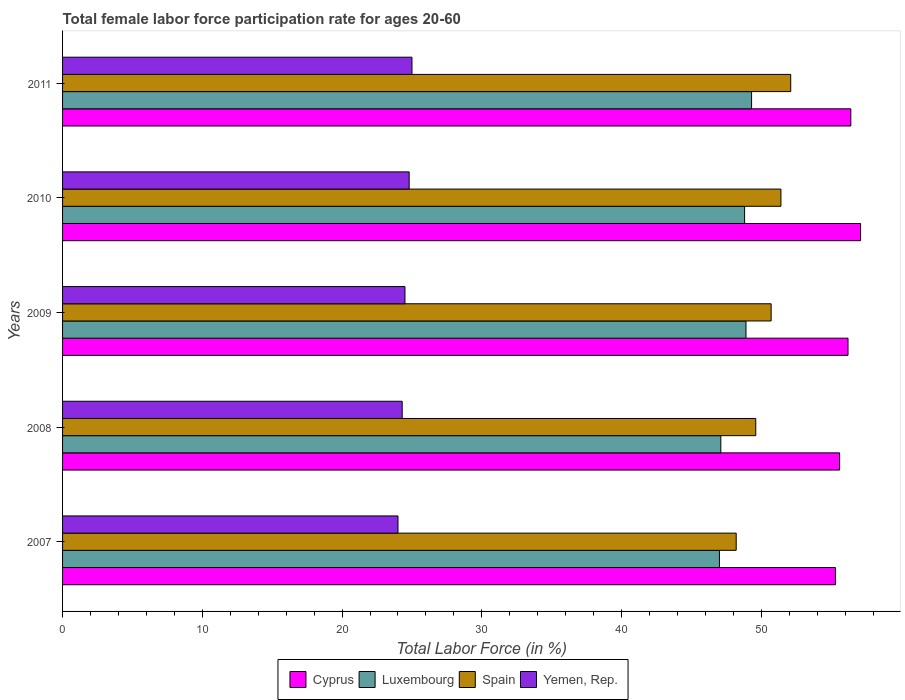How many different coloured bars are there?
Offer a terse response. 4. How many groups of bars are there?
Your answer should be compact. 5. Are the number of bars per tick equal to the number of legend labels?
Keep it short and to the point. Yes. Are the number of bars on each tick of the Y-axis equal?
Ensure brevity in your answer.  Yes. How many bars are there on the 1st tick from the top?
Ensure brevity in your answer.  4. What is the label of the 1st group of bars from the top?
Your answer should be very brief. 2011. In how many cases, is the number of bars for a given year not equal to the number of legend labels?
Your answer should be compact. 0. What is the female labor force participation rate in Spain in 2009?
Provide a short and direct response. 50.7. Across all years, what is the maximum female labor force participation rate in Luxembourg?
Your answer should be compact. 49.3. Across all years, what is the minimum female labor force participation rate in Spain?
Offer a very short reply. 48.2. In which year was the female labor force participation rate in Spain maximum?
Offer a terse response. 2011. What is the total female labor force participation rate in Spain in the graph?
Keep it short and to the point. 252. What is the difference between the female labor force participation rate in Luxembourg in 2009 and that in 2010?
Your response must be concise. 0.1. What is the difference between the female labor force participation rate in Yemen, Rep. in 2009 and the female labor force participation rate in Spain in 2011?
Provide a succinct answer. -27.6. What is the average female labor force participation rate in Spain per year?
Offer a very short reply. 50.4. In the year 2011, what is the difference between the female labor force participation rate in Spain and female labor force participation rate in Yemen, Rep.?
Offer a very short reply. 27.1. What is the ratio of the female labor force participation rate in Luxembourg in 2008 to that in 2010?
Keep it short and to the point. 0.97. Is the female labor force participation rate in Luxembourg in 2009 less than that in 2011?
Your answer should be compact. Yes. Is the difference between the female labor force participation rate in Spain in 2009 and 2010 greater than the difference between the female labor force participation rate in Yemen, Rep. in 2009 and 2010?
Keep it short and to the point. No. What is the difference between the highest and the second highest female labor force participation rate in Luxembourg?
Your answer should be compact. 0.4. What is the difference between the highest and the lowest female labor force participation rate in Spain?
Your answer should be very brief. 3.9. Is it the case that in every year, the sum of the female labor force participation rate in Luxembourg and female labor force participation rate in Yemen, Rep. is greater than the sum of female labor force participation rate in Spain and female labor force participation rate in Cyprus?
Your answer should be compact. Yes. What does the 4th bar from the top in 2008 represents?
Keep it short and to the point. Cyprus. What does the 2nd bar from the bottom in 2007 represents?
Give a very brief answer. Luxembourg. Is it the case that in every year, the sum of the female labor force participation rate in Cyprus and female labor force participation rate in Luxembourg is greater than the female labor force participation rate in Yemen, Rep.?
Keep it short and to the point. Yes. How many bars are there?
Make the answer very short. 20. Are all the bars in the graph horizontal?
Your answer should be very brief. Yes. How many years are there in the graph?
Provide a short and direct response. 5. What is the difference between two consecutive major ticks on the X-axis?
Your response must be concise. 10. Does the graph contain any zero values?
Your response must be concise. No. Does the graph contain grids?
Give a very brief answer. No. How many legend labels are there?
Your response must be concise. 4. How are the legend labels stacked?
Make the answer very short. Horizontal. What is the title of the graph?
Keep it short and to the point. Total female labor force participation rate for ages 20-60. What is the label or title of the X-axis?
Offer a terse response. Total Labor Force (in %). What is the Total Labor Force (in %) of Cyprus in 2007?
Ensure brevity in your answer.  55.3. What is the Total Labor Force (in %) of Luxembourg in 2007?
Keep it short and to the point. 47. What is the Total Labor Force (in %) of Spain in 2007?
Your response must be concise. 48.2. What is the Total Labor Force (in %) in Yemen, Rep. in 2007?
Your answer should be very brief. 24. What is the Total Labor Force (in %) of Cyprus in 2008?
Ensure brevity in your answer.  55.6. What is the Total Labor Force (in %) of Luxembourg in 2008?
Your answer should be very brief. 47.1. What is the Total Labor Force (in %) of Spain in 2008?
Provide a short and direct response. 49.6. What is the Total Labor Force (in %) of Yemen, Rep. in 2008?
Provide a succinct answer. 24.3. What is the Total Labor Force (in %) in Cyprus in 2009?
Your answer should be compact. 56.2. What is the Total Labor Force (in %) of Luxembourg in 2009?
Ensure brevity in your answer.  48.9. What is the Total Labor Force (in %) in Spain in 2009?
Give a very brief answer. 50.7. What is the Total Labor Force (in %) of Yemen, Rep. in 2009?
Your answer should be compact. 24.5. What is the Total Labor Force (in %) in Cyprus in 2010?
Your answer should be compact. 57.1. What is the Total Labor Force (in %) of Luxembourg in 2010?
Your answer should be compact. 48.8. What is the Total Labor Force (in %) of Spain in 2010?
Keep it short and to the point. 51.4. What is the Total Labor Force (in %) of Yemen, Rep. in 2010?
Keep it short and to the point. 24.8. What is the Total Labor Force (in %) of Cyprus in 2011?
Your answer should be very brief. 56.4. What is the Total Labor Force (in %) of Luxembourg in 2011?
Provide a succinct answer. 49.3. What is the Total Labor Force (in %) of Spain in 2011?
Offer a very short reply. 52.1. What is the Total Labor Force (in %) of Yemen, Rep. in 2011?
Your response must be concise. 25. Across all years, what is the maximum Total Labor Force (in %) in Cyprus?
Your answer should be very brief. 57.1. Across all years, what is the maximum Total Labor Force (in %) of Luxembourg?
Your answer should be very brief. 49.3. Across all years, what is the maximum Total Labor Force (in %) of Spain?
Your answer should be very brief. 52.1. Across all years, what is the maximum Total Labor Force (in %) in Yemen, Rep.?
Keep it short and to the point. 25. Across all years, what is the minimum Total Labor Force (in %) in Cyprus?
Your answer should be compact. 55.3. Across all years, what is the minimum Total Labor Force (in %) of Spain?
Your answer should be very brief. 48.2. Across all years, what is the minimum Total Labor Force (in %) of Yemen, Rep.?
Ensure brevity in your answer.  24. What is the total Total Labor Force (in %) of Cyprus in the graph?
Your response must be concise. 280.6. What is the total Total Labor Force (in %) of Luxembourg in the graph?
Offer a very short reply. 241.1. What is the total Total Labor Force (in %) of Spain in the graph?
Offer a very short reply. 252. What is the total Total Labor Force (in %) of Yemen, Rep. in the graph?
Give a very brief answer. 122.6. What is the difference between the Total Labor Force (in %) in Cyprus in 2007 and that in 2008?
Give a very brief answer. -0.3. What is the difference between the Total Labor Force (in %) in Spain in 2007 and that in 2008?
Your answer should be compact. -1.4. What is the difference between the Total Labor Force (in %) of Yemen, Rep. in 2007 and that in 2008?
Make the answer very short. -0.3. What is the difference between the Total Labor Force (in %) in Cyprus in 2007 and that in 2009?
Give a very brief answer. -0.9. What is the difference between the Total Labor Force (in %) in Luxembourg in 2007 and that in 2009?
Your answer should be very brief. -1.9. What is the difference between the Total Labor Force (in %) of Cyprus in 2007 and that in 2010?
Provide a short and direct response. -1.8. What is the difference between the Total Labor Force (in %) in Luxembourg in 2007 and that in 2010?
Your answer should be compact. -1.8. What is the difference between the Total Labor Force (in %) of Cyprus in 2007 and that in 2011?
Offer a terse response. -1.1. What is the difference between the Total Labor Force (in %) of Spain in 2007 and that in 2011?
Provide a short and direct response. -3.9. What is the difference between the Total Labor Force (in %) of Yemen, Rep. in 2007 and that in 2011?
Make the answer very short. -1. What is the difference between the Total Labor Force (in %) in Luxembourg in 2008 and that in 2009?
Provide a short and direct response. -1.8. What is the difference between the Total Labor Force (in %) in Spain in 2008 and that in 2009?
Your answer should be compact. -1.1. What is the difference between the Total Labor Force (in %) in Cyprus in 2008 and that in 2010?
Your answer should be very brief. -1.5. What is the difference between the Total Labor Force (in %) in Luxembourg in 2008 and that in 2010?
Offer a terse response. -1.7. What is the difference between the Total Labor Force (in %) of Yemen, Rep. in 2008 and that in 2010?
Keep it short and to the point. -0.5. What is the difference between the Total Labor Force (in %) in Cyprus in 2008 and that in 2011?
Provide a short and direct response. -0.8. What is the difference between the Total Labor Force (in %) in Luxembourg in 2008 and that in 2011?
Offer a very short reply. -2.2. What is the difference between the Total Labor Force (in %) of Luxembourg in 2009 and that in 2010?
Your answer should be very brief. 0.1. What is the difference between the Total Labor Force (in %) of Yemen, Rep. in 2009 and that in 2010?
Ensure brevity in your answer.  -0.3. What is the difference between the Total Labor Force (in %) in Cyprus in 2009 and that in 2011?
Your response must be concise. -0.2. What is the difference between the Total Labor Force (in %) of Spain in 2009 and that in 2011?
Offer a terse response. -1.4. What is the difference between the Total Labor Force (in %) of Yemen, Rep. in 2009 and that in 2011?
Provide a succinct answer. -0.5. What is the difference between the Total Labor Force (in %) of Cyprus in 2010 and that in 2011?
Your answer should be compact. 0.7. What is the difference between the Total Labor Force (in %) in Cyprus in 2007 and the Total Labor Force (in %) in Spain in 2008?
Provide a succinct answer. 5.7. What is the difference between the Total Labor Force (in %) in Luxembourg in 2007 and the Total Labor Force (in %) in Spain in 2008?
Ensure brevity in your answer.  -2.6. What is the difference between the Total Labor Force (in %) in Luxembourg in 2007 and the Total Labor Force (in %) in Yemen, Rep. in 2008?
Your answer should be compact. 22.7. What is the difference between the Total Labor Force (in %) in Spain in 2007 and the Total Labor Force (in %) in Yemen, Rep. in 2008?
Offer a very short reply. 23.9. What is the difference between the Total Labor Force (in %) in Cyprus in 2007 and the Total Labor Force (in %) in Yemen, Rep. in 2009?
Give a very brief answer. 30.8. What is the difference between the Total Labor Force (in %) of Luxembourg in 2007 and the Total Labor Force (in %) of Spain in 2009?
Your answer should be compact. -3.7. What is the difference between the Total Labor Force (in %) of Spain in 2007 and the Total Labor Force (in %) of Yemen, Rep. in 2009?
Give a very brief answer. 23.7. What is the difference between the Total Labor Force (in %) of Cyprus in 2007 and the Total Labor Force (in %) of Spain in 2010?
Offer a terse response. 3.9. What is the difference between the Total Labor Force (in %) in Cyprus in 2007 and the Total Labor Force (in %) in Yemen, Rep. in 2010?
Keep it short and to the point. 30.5. What is the difference between the Total Labor Force (in %) of Luxembourg in 2007 and the Total Labor Force (in %) of Spain in 2010?
Provide a succinct answer. -4.4. What is the difference between the Total Labor Force (in %) of Spain in 2007 and the Total Labor Force (in %) of Yemen, Rep. in 2010?
Your answer should be very brief. 23.4. What is the difference between the Total Labor Force (in %) of Cyprus in 2007 and the Total Labor Force (in %) of Yemen, Rep. in 2011?
Ensure brevity in your answer.  30.3. What is the difference between the Total Labor Force (in %) of Luxembourg in 2007 and the Total Labor Force (in %) of Spain in 2011?
Ensure brevity in your answer.  -5.1. What is the difference between the Total Labor Force (in %) of Spain in 2007 and the Total Labor Force (in %) of Yemen, Rep. in 2011?
Your answer should be compact. 23.2. What is the difference between the Total Labor Force (in %) of Cyprus in 2008 and the Total Labor Force (in %) of Luxembourg in 2009?
Your answer should be compact. 6.7. What is the difference between the Total Labor Force (in %) in Cyprus in 2008 and the Total Labor Force (in %) in Yemen, Rep. in 2009?
Keep it short and to the point. 31.1. What is the difference between the Total Labor Force (in %) of Luxembourg in 2008 and the Total Labor Force (in %) of Spain in 2009?
Offer a very short reply. -3.6. What is the difference between the Total Labor Force (in %) of Luxembourg in 2008 and the Total Labor Force (in %) of Yemen, Rep. in 2009?
Your answer should be compact. 22.6. What is the difference between the Total Labor Force (in %) in Spain in 2008 and the Total Labor Force (in %) in Yemen, Rep. in 2009?
Your response must be concise. 25.1. What is the difference between the Total Labor Force (in %) of Cyprus in 2008 and the Total Labor Force (in %) of Luxembourg in 2010?
Your answer should be compact. 6.8. What is the difference between the Total Labor Force (in %) in Cyprus in 2008 and the Total Labor Force (in %) in Yemen, Rep. in 2010?
Keep it short and to the point. 30.8. What is the difference between the Total Labor Force (in %) of Luxembourg in 2008 and the Total Labor Force (in %) of Spain in 2010?
Offer a terse response. -4.3. What is the difference between the Total Labor Force (in %) of Luxembourg in 2008 and the Total Labor Force (in %) of Yemen, Rep. in 2010?
Offer a very short reply. 22.3. What is the difference between the Total Labor Force (in %) in Spain in 2008 and the Total Labor Force (in %) in Yemen, Rep. in 2010?
Give a very brief answer. 24.8. What is the difference between the Total Labor Force (in %) of Cyprus in 2008 and the Total Labor Force (in %) of Luxembourg in 2011?
Your answer should be very brief. 6.3. What is the difference between the Total Labor Force (in %) in Cyprus in 2008 and the Total Labor Force (in %) in Yemen, Rep. in 2011?
Offer a very short reply. 30.6. What is the difference between the Total Labor Force (in %) in Luxembourg in 2008 and the Total Labor Force (in %) in Spain in 2011?
Your response must be concise. -5. What is the difference between the Total Labor Force (in %) in Luxembourg in 2008 and the Total Labor Force (in %) in Yemen, Rep. in 2011?
Keep it short and to the point. 22.1. What is the difference between the Total Labor Force (in %) of Spain in 2008 and the Total Labor Force (in %) of Yemen, Rep. in 2011?
Ensure brevity in your answer.  24.6. What is the difference between the Total Labor Force (in %) in Cyprus in 2009 and the Total Labor Force (in %) in Spain in 2010?
Your answer should be very brief. 4.8. What is the difference between the Total Labor Force (in %) of Cyprus in 2009 and the Total Labor Force (in %) of Yemen, Rep. in 2010?
Provide a short and direct response. 31.4. What is the difference between the Total Labor Force (in %) of Luxembourg in 2009 and the Total Labor Force (in %) of Spain in 2010?
Your response must be concise. -2.5. What is the difference between the Total Labor Force (in %) in Luxembourg in 2009 and the Total Labor Force (in %) in Yemen, Rep. in 2010?
Provide a short and direct response. 24.1. What is the difference between the Total Labor Force (in %) in Spain in 2009 and the Total Labor Force (in %) in Yemen, Rep. in 2010?
Keep it short and to the point. 25.9. What is the difference between the Total Labor Force (in %) in Cyprus in 2009 and the Total Labor Force (in %) in Luxembourg in 2011?
Ensure brevity in your answer.  6.9. What is the difference between the Total Labor Force (in %) of Cyprus in 2009 and the Total Labor Force (in %) of Spain in 2011?
Your response must be concise. 4.1. What is the difference between the Total Labor Force (in %) in Cyprus in 2009 and the Total Labor Force (in %) in Yemen, Rep. in 2011?
Keep it short and to the point. 31.2. What is the difference between the Total Labor Force (in %) of Luxembourg in 2009 and the Total Labor Force (in %) of Spain in 2011?
Provide a succinct answer. -3.2. What is the difference between the Total Labor Force (in %) in Luxembourg in 2009 and the Total Labor Force (in %) in Yemen, Rep. in 2011?
Your answer should be compact. 23.9. What is the difference between the Total Labor Force (in %) in Spain in 2009 and the Total Labor Force (in %) in Yemen, Rep. in 2011?
Make the answer very short. 25.7. What is the difference between the Total Labor Force (in %) of Cyprus in 2010 and the Total Labor Force (in %) of Spain in 2011?
Ensure brevity in your answer.  5. What is the difference between the Total Labor Force (in %) of Cyprus in 2010 and the Total Labor Force (in %) of Yemen, Rep. in 2011?
Provide a succinct answer. 32.1. What is the difference between the Total Labor Force (in %) of Luxembourg in 2010 and the Total Labor Force (in %) of Yemen, Rep. in 2011?
Provide a short and direct response. 23.8. What is the difference between the Total Labor Force (in %) of Spain in 2010 and the Total Labor Force (in %) of Yemen, Rep. in 2011?
Keep it short and to the point. 26.4. What is the average Total Labor Force (in %) of Cyprus per year?
Your answer should be compact. 56.12. What is the average Total Labor Force (in %) of Luxembourg per year?
Give a very brief answer. 48.22. What is the average Total Labor Force (in %) of Spain per year?
Your answer should be compact. 50.4. What is the average Total Labor Force (in %) of Yemen, Rep. per year?
Ensure brevity in your answer.  24.52. In the year 2007, what is the difference between the Total Labor Force (in %) of Cyprus and Total Labor Force (in %) of Yemen, Rep.?
Offer a terse response. 31.3. In the year 2007, what is the difference between the Total Labor Force (in %) in Luxembourg and Total Labor Force (in %) in Spain?
Your answer should be very brief. -1.2. In the year 2007, what is the difference between the Total Labor Force (in %) in Spain and Total Labor Force (in %) in Yemen, Rep.?
Your response must be concise. 24.2. In the year 2008, what is the difference between the Total Labor Force (in %) in Cyprus and Total Labor Force (in %) in Yemen, Rep.?
Provide a succinct answer. 31.3. In the year 2008, what is the difference between the Total Labor Force (in %) of Luxembourg and Total Labor Force (in %) of Spain?
Your answer should be compact. -2.5. In the year 2008, what is the difference between the Total Labor Force (in %) in Luxembourg and Total Labor Force (in %) in Yemen, Rep.?
Your answer should be compact. 22.8. In the year 2008, what is the difference between the Total Labor Force (in %) in Spain and Total Labor Force (in %) in Yemen, Rep.?
Give a very brief answer. 25.3. In the year 2009, what is the difference between the Total Labor Force (in %) in Cyprus and Total Labor Force (in %) in Luxembourg?
Keep it short and to the point. 7.3. In the year 2009, what is the difference between the Total Labor Force (in %) of Cyprus and Total Labor Force (in %) of Yemen, Rep.?
Provide a succinct answer. 31.7. In the year 2009, what is the difference between the Total Labor Force (in %) in Luxembourg and Total Labor Force (in %) in Spain?
Your response must be concise. -1.8. In the year 2009, what is the difference between the Total Labor Force (in %) in Luxembourg and Total Labor Force (in %) in Yemen, Rep.?
Your response must be concise. 24.4. In the year 2009, what is the difference between the Total Labor Force (in %) in Spain and Total Labor Force (in %) in Yemen, Rep.?
Your response must be concise. 26.2. In the year 2010, what is the difference between the Total Labor Force (in %) in Cyprus and Total Labor Force (in %) in Spain?
Give a very brief answer. 5.7. In the year 2010, what is the difference between the Total Labor Force (in %) in Cyprus and Total Labor Force (in %) in Yemen, Rep.?
Give a very brief answer. 32.3. In the year 2010, what is the difference between the Total Labor Force (in %) of Luxembourg and Total Labor Force (in %) of Spain?
Offer a terse response. -2.6. In the year 2010, what is the difference between the Total Labor Force (in %) in Spain and Total Labor Force (in %) in Yemen, Rep.?
Keep it short and to the point. 26.6. In the year 2011, what is the difference between the Total Labor Force (in %) of Cyprus and Total Labor Force (in %) of Yemen, Rep.?
Your answer should be compact. 31.4. In the year 2011, what is the difference between the Total Labor Force (in %) in Luxembourg and Total Labor Force (in %) in Yemen, Rep.?
Your answer should be compact. 24.3. In the year 2011, what is the difference between the Total Labor Force (in %) in Spain and Total Labor Force (in %) in Yemen, Rep.?
Offer a terse response. 27.1. What is the ratio of the Total Labor Force (in %) of Spain in 2007 to that in 2008?
Your answer should be compact. 0.97. What is the ratio of the Total Labor Force (in %) of Yemen, Rep. in 2007 to that in 2008?
Your answer should be compact. 0.99. What is the ratio of the Total Labor Force (in %) of Cyprus in 2007 to that in 2009?
Make the answer very short. 0.98. What is the ratio of the Total Labor Force (in %) in Luxembourg in 2007 to that in 2009?
Give a very brief answer. 0.96. What is the ratio of the Total Labor Force (in %) in Spain in 2007 to that in 2009?
Make the answer very short. 0.95. What is the ratio of the Total Labor Force (in %) of Yemen, Rep. in 2007 to that in 2009?
Your answer should be compact. 0.98. What is the ratio of the Total Labor Force (in %) in Cyprus in 2007 to that in 2010?
Ensure brevity in your answer.  0.97. What is the ratio of the Total Labor Force (in %) in Luxembourg in 2007 to that in 2010?
Make the answer very short. 0.96. What is the ratio of the Total Labor Force (in %) of Spain in 2007 to that in 2010?
Give a very brief answer. 0.94. What is the ratio of the Total Labor Force (in %) in Yemen, Rep. in 2007 to that in 2010?
Your answer should be compact. 0.97. What is the ratio of the Total Labor Force (in %) in Cyprus in 2007 to that in 2011?
Provide a short and direct response. 0.98. What is the ratio of the Total Labor Force (in %) in Luxembourg in 2007 to that in 2011?
Ensure brevity in your answer.  0.95. What is the ratio of the Total Labor Force (in %) in Spain in 2007 to that in 2011?
Provide a succinct answer. 0.93. What is the ratio of the Total Labor Force (in %) in Cyprus in 2008 to that in 2009?
Provide a short and direct response. 0.99. What is the ratio of the Total Labor Force (in %) of Luxembourg in 2008 to that in 2009?
Your answer should be compact. 0.96. What is the ratio of the Total Labor Force (in %) in Spain in 2008 to that in 2009?
Your answer should be very brief. 0.98. What is the ratio of the Total Labor Force (in %) of Cyprus in 2008 to that in 2010?
Give a very brief answer. 0.97. What is the ratio of the Total Labor Force (in %) of Luxembourg in 2008 to that in 2010?
Keep it short and to the point. 0.97. What is the ratio of the Total Labor Force (in %) in Spain in 2008 to that in 2010?
Give a very brief answer. 0.96. What is the ratio of the Total Labor Force (in %) in Yemen, Rep. in 2008 to that in 2010?
Give a very brief answer. 0.98. What is the ratio of the Total Labor Force (in %) in Cyprus in 2008 to that in 2011?
Ensure brevity in your answer.  0.99. What is the ratio of the Total Labor Force (in %) in Luxembourg in 2008 to that in 2011?
Keep it short and to the point. 0.96. What is the ratio of the Total Labor Force (in %) of Yemen, Rep. in 2008 to that in 2011?
Make the answer very short. 0.97. What is the ratio of the Total Labor Force (in %) of Cyprus in 2009 to that in 2010?
Provide a short and direct response. 0.98. What is the ratio of the Total Labor Force (in %) of Spain in 2009 to that in 2010?
Your answer should be compact. 0.99. What is the ratio of the Total Labor Force (in %) of Yemen, Rep. in 2009 to that in 2010?
Ensure brevity in your answer.  0.99. What is the ratio of the Total Labor Force (in %) of Cyprus in 2009 to that in 2011?
Provide a succinct answer. 1. What is the ratio of the Total Labor Force (in %) in Spain in 2009 to that in 2011?
Provide a short and direct response. 0.97. What is the ratio of the Total Labor Force (in %) of Yemen, Rep. in 2009 to that in 2011?
Ensure brevity in your answer.  0.98. What is the ratio of the Total Labor Force (in %) of Cyprus in 2010 to that in 2011?
Give a very brief answer. 1.01. What is the ratio of the Total Labor Force (in %) in Spain in 2010 to that in 2011?
Offer a terse response. 0.99. What is the difference between the highest and the second highest Total Labor Force (in %) in Cyprus?
Your response must be concise. 0.7. What is the difference between the highest and the second highest Total Labor Force (in %) in Luxembourg?
Provide a short and direct response. 0.4. What is the difference between the highest and the second highest Total Labor Force (in %) in Spain?
Make the answer very short. 0.7. What is the difference between the highest and the lowest Total Labor Force (in %) in Cyprus?
Your answer should be compact. 1.8. What is the difference between the highest and the lowest Total Labor Force (in %) of Luxembourg?
Give a very brief answer. 2.3. What is the difference between the highest and the lowest Total Labor Force (in %) in Yemen, Rep.?
Your answer should be compact. 1. 